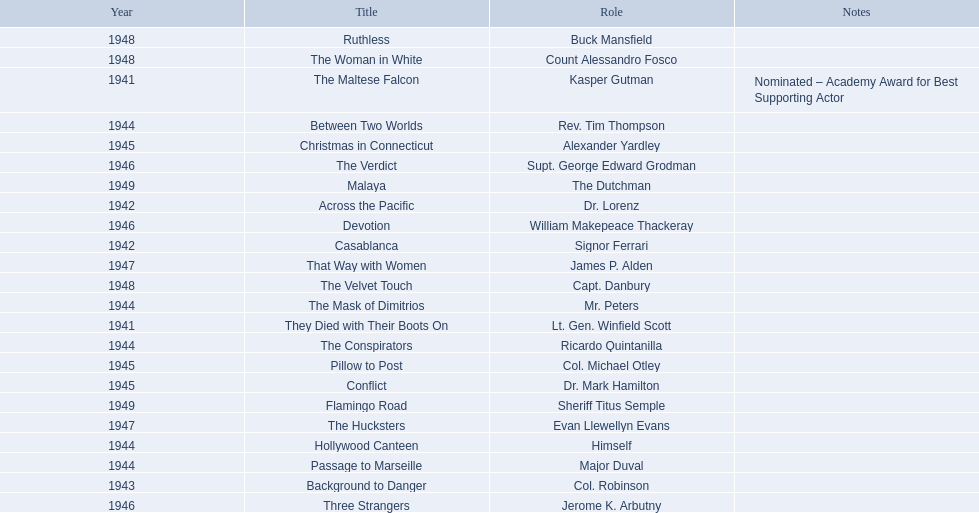What year was the movie that was nominated ? 1941. What was the title of the movie? The Maltese Falcon. 